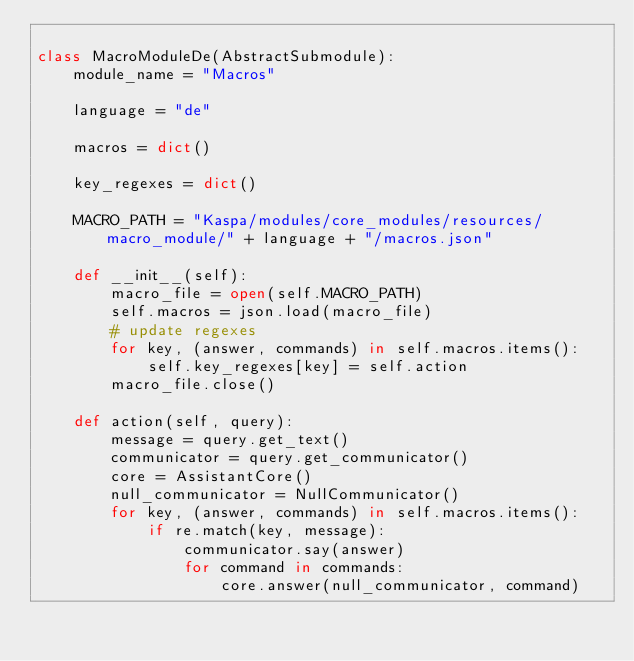<code> <loc_0><loc_0><loc_500><loc_500><_Python_>
class MacroModuleDe(AbstractSubmodule):
    module_name = "Macros"

    language = "de"

    macros = dict()

    key_regexes = dict()

    MACRO_PATH = "Kaspa/modules/core_modules/resources/macro_module/" + language + "/macros.json"

    def __init__(self):
        macro_file = open(self.MACRO_PATH)
        self.macros = json.load(macro_file)
        # update regexes
        for key, (answer, commands) in self.macros.items():
            self.key_regexes[key] = self.action
        macro_file.close()

    def action(self, query):
        message = query.get_text()
        communicator = query.get_communicator()
        core = AssistantCore()
        null_communicator = NullCommunicator()
        for key, (answer, commands) in self.macros.items():
            if re.match(key, message):
                communicator.say(answer)
                for command in commands:
                    core.answer(null_communicator, command)
</code> 